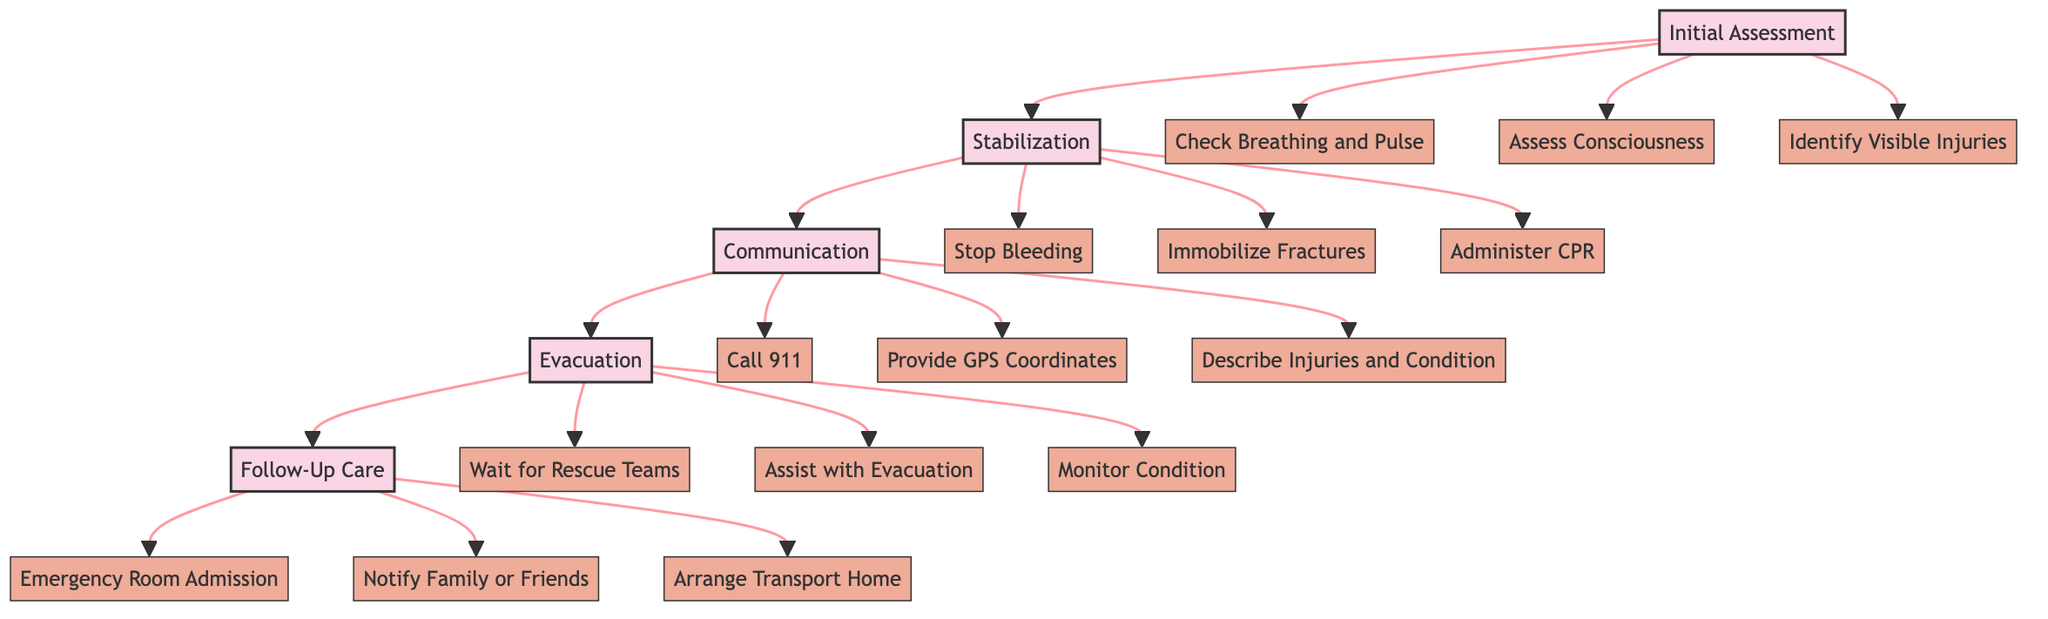What is the first step in the pathway? The diagram clearly indicates that the first step is "Initial Assessment," which is the starting point for the Emergency Medical Response Pathway for Hikers.
Answer: Initial Assessment How many substeps are there in the "Stabilization" step? By counting the branches under the "Stabilization" step, we find three substeps: "Stop Bleeding," "Immobilize Fractures," and "Administer CPR." Therefore, there are a total of three substeps.
Answer: 3 What follows the "Communication" step? The diagram shows that after the "Communication" step, the next step is "Evacuation," indicating the flow of actions taken in case of an emergency.
Answer: Evacuation Which substep involves contacting emergency services? Looking at the substeps under "Communication," the substep titled "Call 911" specifically involves contacting emergency services for assistance.
Answer: Call 911 What is the last step shown in the diagram? The final step indicated in the pathway is "Follow-Up Care," which includes ensuring that the hiker receives appropriate medical treatment and follow-up after the emergency situation.
Answer: Follow-Up Care Explain the relationship between "Stabilization" and "Initial Assessment." The "Stabilization" step follows directly after the "Initial Assessment" step, which means that once the initial assessment of the hiker's condition is done, the next action is to provide immediate care to stabilize their condition.
Answer: Stabilization follows Initial Assessment What is the purpose of the "Evacuation" step? The diagram designates "Evacuation" as the step for safely transporting the hiker to the nearest medical facility, emphasizing the critical action required after assessing and stabilizing the hiker's condition.
Answer: Safely transport to medical facility How many total main steps are in this pathway? Upon examining the diagram, there are five main steps listed: "Initial Assessment," "Stabilization," "Communication," "Evacuation," and "Follow-Up Care," totaling five distinct steps in the pathway.
Answer: 5 What is required when "Administer CPR" is a necessary action? The corresponding substep, "Administer CPR," indicates that this action is required if the hiker's condition is critical, specifically if they are not breathing or have no pulse, thus necessitating immediate resuscitation efforts.
Answer: If necessary 